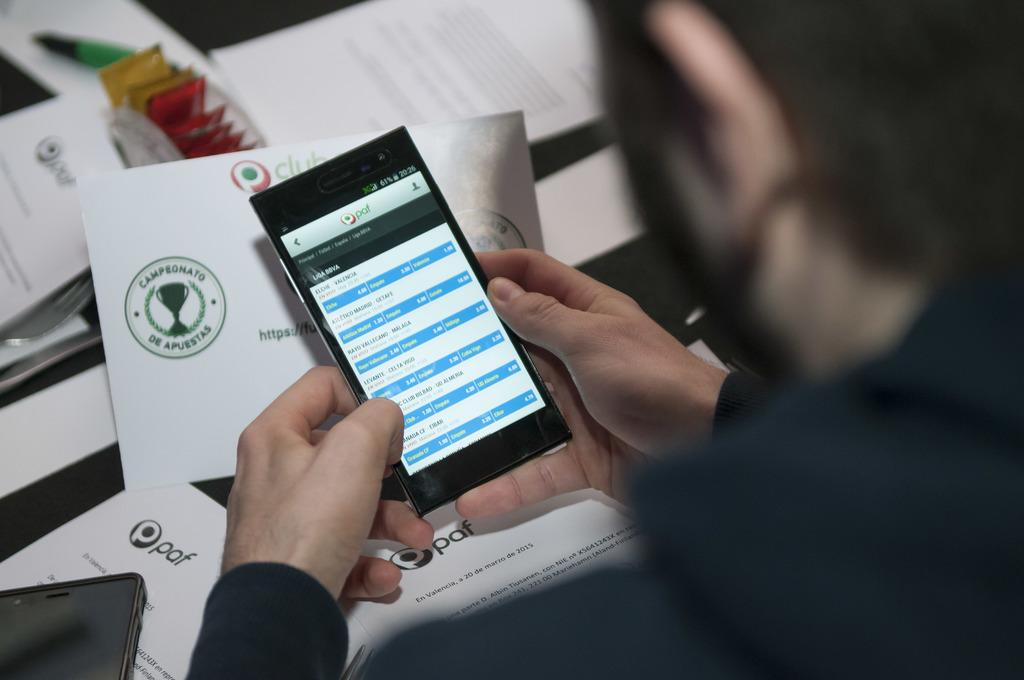What is the person in the image doing? The person is holding a mobile phone. What part of the person's body is visible in the image? Human hands are visible in the image. What can be seen in the background of the image? There are papers with text on them in the background of the image. What type of polish is the person applying to their nails in the image? There is no indication in the image that the person is applying polish to their nails. How many crows are visible in the image? There are no crows present in the image. 